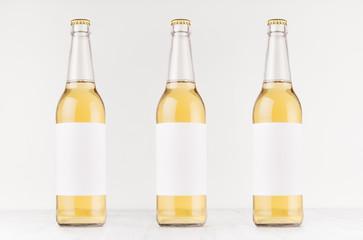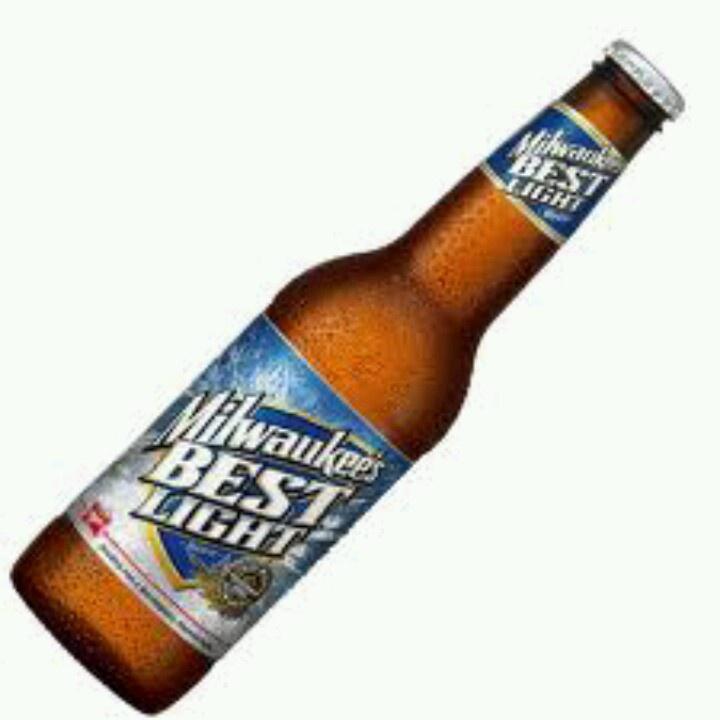The first image is the image on the left, the second image is the image on the right. For the images displayed, is the sentence "All beer bottles are standing upright." factually correct? Answer yes or no. No. The first image is the image on the left, the second image is the image on the right. Examine the images to the left and right. Is the description "There are three green glass bottles" accurate? Answer yes or no. No. 